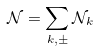Convert formula to latex. <formula><loc_0><loc_0><loc_500><loc_500>\mathcal { N } = \sum _ { k , \pm } \mathcal { N } _ { k }</formula> 